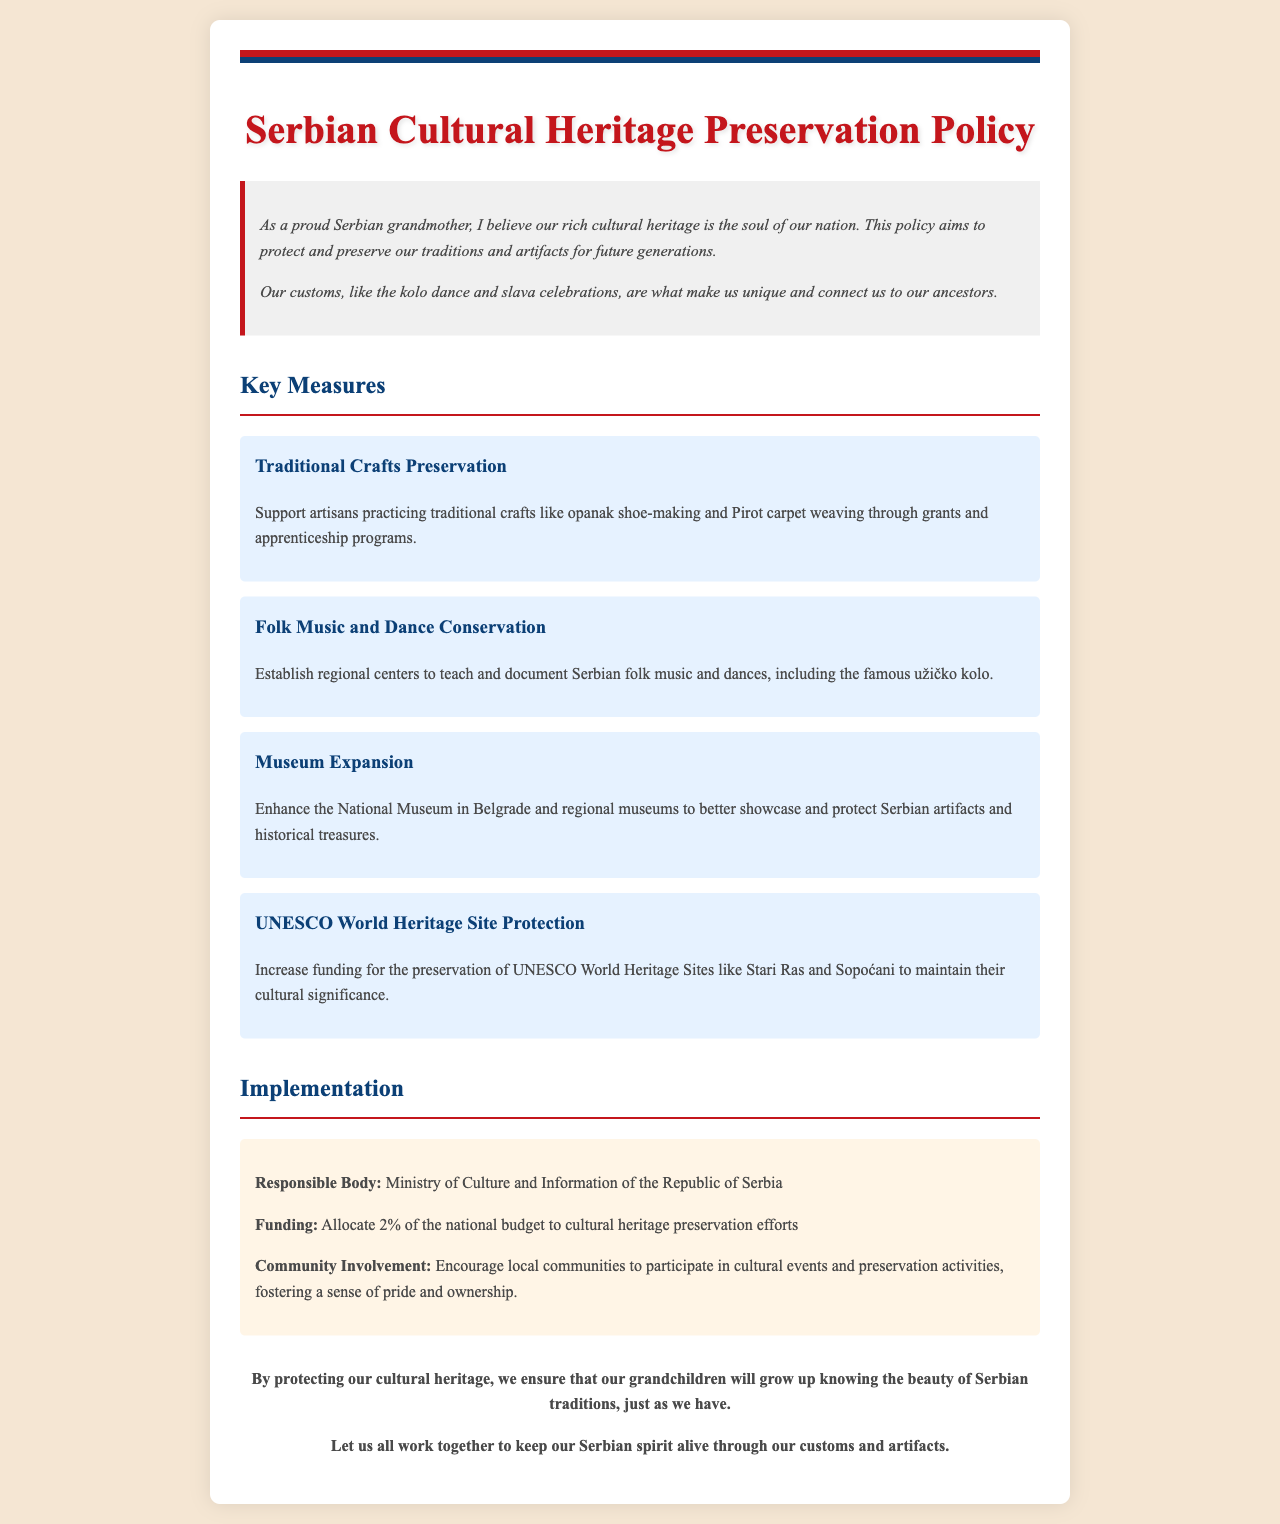what is the title of the policy document? The title of the document is presented prominently at the top of the page.
Answer: Serbian Cultural Heritage Preservation Policy who is responsible for the preservation policy? The responsible body is mentioned in the implementation section of the document.
Answer: Ministry of Culture and Information of the Republic of Serbia what percentage of the national budget is allocated to cultural heritage preservation? The document specifies the funding allocation as a percentage within the implementation section.
Answer: 2% which traditional craft is specifically mentioned for preservation? The document lists specific crafts under key measures for preservation.
Answer: opanak shoe-making name one UNESCO World Heritage Site mentioned in the document. The document highlights a specific UNESCO site within the measures section.
Answer: Stari Ras what is the main purpose of this policy document? The purpose of the document is summarized in the introduction.
Answer: Protect and preserve our traditions and artifacts how does the policy plan to support traditional crafts? The document outlines measures to assist artisans in practicing their crafts.
Answer: Grants and apprenticeship programs what cultural event is encouraged for community involvement? The document states the types of activities for local community involvement.
Answer: Cultural events and preservation activities 